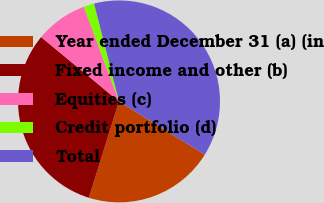<chart> <loc_0><loc_0><loc_500><loc_500><pie_chart><fcel>Year ended December 31 (a) (in<fcel>Fixed income and other (b)<fcel>Equities (c)<fcel>Credit portfolio (d)<fcel>Total<nl><fcel>20.98%<fcel>31.16%<fcel>8.35%<fcel>1.69%<fcel>37.82%<nl></chart> 